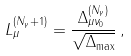Convert formula to latex. <formula><loc_0><loc_0><loc_500><loc_500>L _ { \mu } ^ { ( N _ { \gamma } + 1 ) } = \frac { \Delta _ { \mu \nu _ { 0 } } ^ { ( N _ { \gamma } ) } } { \sqrt { \Delta _ { \max } } } \, ,</formula> 